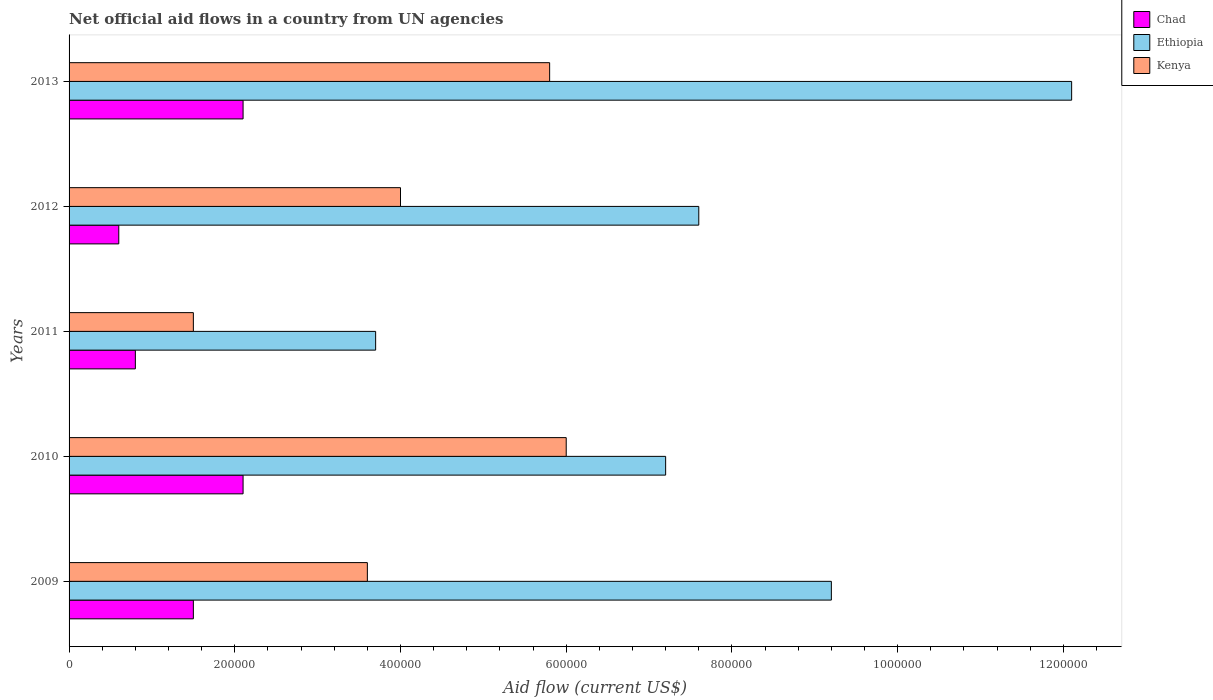What is the net official aid flow in Ethiopia in 2010?
Ensure brevity in your answer.  7.20e+05. Across all years, what is the maximum net official aid flow in Chad?
Your answer should be very brief. 2.10e+05. Across all years, what is the minimum net official aid flow in Chad?
Your response must be concise. 6.00e+04. In which year was the net official aid flow in Kenya maximum?
Your answer should be very brief. 2010. What is the total net official aid flow in Ethiopia in the graph?
Your answer should be compact. 3.98e+06. What is the difference between the net official aid flow in Kenya in 2009 and that in 2010?
Make the answer very short. -2.40e+05. What is the difference between the net official aid flow in Kenya in 2010 and the net official aid flow in Ethiopia in 2011?
Make the answer very short. 2.30e+05. What is the average net official aid flow in Chad per year?
Offer a very short reply. 1.42e+05. In the year 2011, what is the difference between the net official aid flow in Ethiopia and net official aid flow in Chad?
Your response must be concise. 2.90e+05. What is the ratio of the net official aid flow in Ethiopia in 2011 to that in 2013?
Keep it short and to the point. 0.31. Is the net official aid flow in Kenya in 2012 less than that in 2013?
Give a very brief answer. Yes. What is the difference between the highest and the lowest net official aid flow in Chad?
Your response must be concise. 1.50e+05. What does the 2nd bar from the top in 2013 represents?
Offer a very short reply. Ethiopia. What does the 1st bar from the bottom in 2012 represents?
Make the answer very short. Chad. Are all the bars in the graph horizontal?
Give a very brief answer. Yes. Are the values on the major ticks of X-axis written in scientific E-notation?
Your response must be concise. No. Where does the legend appear in the graph?
Your answer should be compact. Top right. How many legend labels are there?
Your response must be concise. 3. How are the legend labels stacked?
Provide a succinct answer. Vertical. What is the title of the graph?
Ensure brevity in your answer.  Net official aid flows in a country from UN agencies. What is the label or title of the Y-axis?
Provide a succinct answer. Years. What is the Aid flow (current US$) in Ethiopia in 2009?
Your answer should be compact. 9.20e+05. What is the Aid flow (current US$) in Kenya in 2009?
Offer a very short reply. 3.60e+05. What is the Aid flow (current US$) in Chad in 2010?
Your answer should be very brief. 2.10e+05. What is the Aid flow (current US$) of Ethiopia in 2010?
Provide a succinct answer. 7.20e+05. What is the Aid flow (current US$) of Kenya in 2010?
Give a very brief answer. 6.00e+05. What is the Aid flow (current US$) of Ethiopia in 2011?
Make the answer very short. 3.70e+05. What is the Aid flow (current US$) in Chad in 2012?
Make the answer very short. 6.00e+04. What is the Aid flow (current US$) of Ethiopia in 2012?
Make the answer very short. 7.60e+05. What is the Aid flow (current US$) of Ethiopia in 2013?
Offer a very short reply. 1.21e+06. What is the Aid flow (current US$) of Kenya in 2013?
Give a very brief answer. 5.80e+05. Across all years, what is the maximum Aid flow (current US$) of Ethiopia?
Your response must be concise. 1.21e+06. Across all years, what is the maximum Aid flow (current US$) in Kenya?
Give a very brief answer. 6.00e+05. Across all years, what is the minimum Aid flow (current US$) in Chad?
Ensure brevity in your answer.  6.00e+04. Across all years, what is the minimum Aid flow (current US$) in Kenya?
Make the answer very short. 1.50e+05. What is the total Aid flow (current US$) in Chad in the graph?
Provide a short and direct response. 7.10e+05. What is the total Aid flow (current US$) of Ethiopia in the graph?
Keep it short and to the point. 3.98e+06. What is the total Aid flow (current US$) in Kenya in the graph?
Make the answer very short. 2.09e+06. What is the difference between the Aid flow (current US$) in Chad in 2009 and that in 2010?
Provide a short and direct response. -6.00e+04. What is the difference between the Aid flow (current US$) of Kenya in 2009 and that in 2010?
Offer a very short reply. -2.40e+05. What is the difference between the Aid flow (current US$) of Ethiopia in 2009 and that in 2011?
Ensure brevity in your answer.  5.50e+05. What is the difference between the Aid flow (current US$) in Chad in 2009 and that in 2012?
Provide a short and direct response. 9.00e+04. What is the difference between the Aid flow (current US$) in Ethiopia in 2009 and that in 2012?
Provide a short and direct response. 1.60e+05. What is the difference between the Aid flow (current US$) in Kenya in 2009 and that in 2012?
Keep it short and to the point. -4.00e+04. What is the difference between the Aid flow (current US$) of Chad in 2009 and that in 2013?
Offer a very short reply. -6.00e+04. What is the difference between the Aid flow (current US$) in Chad in 2010 and that in 2011?
Ensure brevity in your answer.  1.30e+05. What is the difference between the Aid flow (current US$) of Ethiopia in 2010 and that in 2011?
Offer a very short reply. 3.50e+05. What is the difference between the Aid flow (current US$) in Kenya in 2010 and that in 2011?
Your response must be concise. 4.50e+05. What is the difference between the Aid flow (current US$) of Ethiopia in 2010 and that in 2012?
Make the answer very short. -4.00e+04. What is the difference between the Aid flow (current US$) of Chad in 2010 and that in 2013?
Provide a succinct answer. 0. What is the difference between the Aid flow (current US$) in Ethiopia in 2010 and that in 2013?
Ensure brevity in your answer.  -4.90e+05. What is the difference between the Aid flow (current US$) in Chad in 2011 and that in 2012?
Provide a succinct answer. 2.00e+04. What is the difference between the Aid flow (current US$) of Ethiopia in 2011 and that in 2012?
Ensure brevity in your answer.  -3.90e+05. What is the difference between the Aid flow (current US$) of Chad in 2011 and that in 2013?
Your response must be concise. -1.30e+05. What is the difference between the Aid flow (current US$) of Ethiopia in 2011 and that in 2013?
Make the answer very short. -8.40e+05. What is the difference between the Aid flow (current US$) of Kenya in 2011 and that in 2013?
Your response must be concise. -4.30e+05. What is the difference between the Aid flow (current US$) of Ethiopia in 2012 and that in 2013?
Provide a succinct answer. -4.50e+05. What is the difference between the Aid flow (current US$) in Chad in 2009 and the Aid flow (current US$) in Ethiopia in 2010?
Your answer should be very brief. -5.70e+05. What is the difference between the Aid flow (current US$) of Chad in 2009 and the Aid flow (current US$) of Kenya in 2010?
Your answer should be very brief. -4.50e+05. What is the difference between the Aid flow (current US$) of Chad in 2009 and the Aid flow (current US$) of Kenya in 2011?
Keep it short and to the point. 0. What is the difference between the Aid flow (current US$) of Ethiopia in 2009 and the Aid flow (current US$) of Kenya in 2011?
Your answer should be compact. 7.70e+05. What is the difference between the Aid flow (current US$) in Chad in 2009 and the Aid flow (current US$) in Ethiopia in 2012?
Provide a succinct answer. -6.10e+05. What is the difference between the Aid flow (current US$) of Chad in 2009 and the Aid flow (current US$) of Kenya in 2012?
Your answer should be compact. -2.50e+05. What is the difference between the Aid flow (current US$) of Ethiopia in 2009 and the Aid flow (current US$) of Kenya in 2012?
Provide a short and direct response. 5.20e+05. What is the difference between the Aid flow (current US$) of Chad in 2009 and the Aid flow (current US$) of Ethiopia in 2013?
Keep it short and to the point. -1.06e+06. What is the difference between the Aid flow (current US$) in Chad in 2009 and the Aid flow (current US$) in Kenya in 2013?
Provide a short and direct response. -4.30e+05. What is the difference between the Aid flow (current US$) of Ethiopia in 2009 and the Aid flow (current US$) of Kenya in 2013?
Ensure brevity in your answer.  3.40e+05. What is the difference between the Aid flow (current US$) in Chad in 2010 and the Aid flow (current US$) in Ethiopia in 2011?
Your answer should be very brief. -1.60e+05. What is the difference between the Aid flow (current US$) of Chad in 2010 and the Aid flow (current US$) of Kenya in 2011?
Your answer should be very brief. 6.00e+04. What is the difference between the Aid flow (current US$) of Ethiopia in 2010 and the Aid flow (current US$) of Kenya in 2011?
Provide a short and direct response. 5.70e+05. What is the difference between the Aid flow (current US$) of Chad in 2010 and the Aid flow (current US$) of Ethiopia in 2012?
Ensure brevity in your answer.  -5.50e+05. What is the difference between the Aid flow (current US$) in Chad in 2010 and the Aid flow (current US$) in Ethiopia in 2013?
Ensure brevity in your answer.  -1.00e+06. What is the difference between the Aid flow (current US$) in Chad in 2010 and the Aid flow (current US$) in Kenya in 2013?
Your response must be concise. -3.70e+05. What is the difference between the Aid flow (current US$) in Ethiopia in 2010 and the Aid flow (current US$) in Kenya in 2013?
Provide a short and direct response. 1.40e+05. What is the difference between the Aid flow (current US$) of Chad in 2011 and the Aid flow (current US$) of Ethiopia in 2012?
Make the answer very short. -6.80e+05. What is the difference between the Aid flow (current US$) in Chad in 2011 and the Aid flow (current US$) in Kenya in 2012?
Provide a short and direct response. -3.20e+05. What is the difference between the Aid flow (current US$) in Chad in 2011 and the Aid flow (current US$) in Ethiopia in 2013?
Your answer should be very brief. -1.13e+06. What is the difference between the Aid flow (current US$) in Chad in 2011 and the Aid flow (current US$) in Kenya in 2013?
Offer a very short reply. -5.00e+05. What is the difference between the Aid flow (current US$) in Ethiopia in 2011 and the Aid flow (current US$) in Kenya in 2013?
Make the answer very short. -2.10e+05. What is the difference between the Aid flow (current US$) in Chad in 2012 and the Aid flow (current US$) in Ethiopia in 2013?
Ensure brevity in your answer.  -1.15e+06. What is the difference between the Aid flow (current US$) of Chad in 2012 and the Aid flow (current US$) of Kenya in 2013?
Make the answer very short. -5.20e+05. What is the difference between the Aid flow (current US$) in Ethiopia in 2012 and the Aid flow (current US$) in Kenya in 2013?
Provide a short and direct response. 1.80e+05. What is the average Aid flow (current US$) of Chad per year?
Keep it short and to the point. 1.42e+05. What is the average Aid flow (current US$) in Ethiopia per year?
Make the answer very short. 7.96e+05. What is the average Aid flow (current US$) of Kenya per year?
Provide a short and direct response. 4.18e+05. In the year 2009, what is the difference between the Aid flow (current US$) in Chad and Aid flow (current US$) in Ethiopia?
Keep it short and to the point. -7.70e+05. In the year 2009, what is the difference between the Aid flow (current US$) in Ethiopia and Aid flow (current US$) in Kenya?
Provide a succinct answer. 5.60e+05. In the year 2010, what is the difference between the Aid flow (current US$) of Chad and Aid flow (current US$) of Ethiopia?
Offer a very short reply. -5.10e+05. In the year 2010, what is the difference between the Aid flow (current US$) of Chad and Aid flow (current US$) of Kenya?
Ensure brevity in your answer.  -3.90e+05. In the year 2011, what is the difference between the Aid flow (current US$) in Chad and Aid flow (current US$) in Ethiopia?
Your answer should be very brief. -2.90e+05. In the year 2012, what is the difference between the Aid flow (current US$) of Chad and Aid flow (current US$) of Ethiopia?
Your answer should be compact. -7.00e+05. In the year 2012, what is the difference between the Aid flow (current US$) in Chad and Aid flow (current US$) in Kenya?
Offer a very short reply. -3.40e+05. In the year 2012, what is the difference between the Aid flow (current US$) in Ethiopia and Aid flow (current US$) in Kenya?
Give a very brief answer. 3.60e+05. In the year 2013, what is the difference between the Aid flow (current US$) of Chad and Aid flow (current US$) of Kenya?
Your answer should be very brief. -3.70e+05. In the year 2013, what is the difference between the Aid flow (current US$) of Ethiopia and Aid flow (current US$) of Kenya?
Give a very brief answer. 6.30e+05. What is the ratio of the Aid flow (current US$) in Ethiopia in 2009 to that in 2010?
Provide a succinct answer. 1.28. What is the ratio of the Aid flow (current US$) in Chad in 2009 to that in 2011?
Provide a short and direct response. 1.88. What is the ratio of the Aid flow (current US$) of Ethiopia in 2009 to that in 2011?
Ensure brevity in your answer.  2.49. What is the ratio of the Aid flow (current US$) of Kenya in 2009 to that in 2011?
Your answer should be very brief. 2.4. What is the ratio of the Aid flow (current US$) of Chad in 2009 to that in 2012?
Your answer should be compact. 2.5. What is the ratio of the Aid flow (current US$) of Ethiopia in 2009 to that in 2012?
Offer a terse response. 1.21. What is the ratio of the Aid flow (current US$) in Kenya in 2009 to that in 2012?
Your response must be concise. 0.9. What is the ratio of the Aid flow (current US$) in Chad in 2009 to that in 2013?
Ensure brevity in your answer.  0.71. What is the ratio of the Aid flow (current US$) of Ethiopia in 2009 to that in 2013?
Give a very brief answer. 0.76. What is the ratio of the Aid flow (current US$) in Kenya in 2009 to that in 2013?
Offer a very short reply. 0.62. What is the ratio of the Aid flow (current US$) in Chad in 2010 to that in 2011?
Your response must be concise. 2.62. What is the ratio of the Aid flow (current US$) in Ethiopia in 2010 to that in 2011?
Offer a terse response. 1.95. What is the ratio of the Aid flow (current US$) of Chad in 2010 to that in 2012?
Give a very brief answer. 3.5. What is the ratio of the Aid flow (current US$) of Ethiopia in 2010 to that in 2012?
Offer a terse response. 0.95. What is the ratio of the Aid flow (current US$) in Kenya in 2010 to that in 2012?
Provide a short and direct response. 1.5. What is the ratio of the Aid flow (current US$) of Ethiopia in 2010 to that in 2013?
Provide a short and direct response. 0.59. What is the ratio of the Aid flow (current US$) in Kenya in 2010 to that in 2013?
Your response must be concise. 1.03. What is the ratio of the Aid flow (current US$) in Ethiopia in 2011 to that in 2012?
Provide a succinct answer. 0.49. What is the ratio of the Aid flow (current US$) of Kenya in 2011 to that in 2012?
Your response must be concise. 0.38. What is the ratio of the Aid flow (current US$) of Chad in 2011 to that in 2013?
Ensure brevity in your answer.  0.38. What is the ratio of the Aid flow (current US$) in Ethiopia in 2011 to that in 2013?
Make the answer very short. 0.31. What is the ratio of the Aid flow (current US$) of Kenya in 2011 to that in 2013?
Provide a short and direct response. 0.26. What is the ratio of the Aid flow (current US$) of Chad in 2012 to that in 2013?
Make the answer very short. 0.29. What is the ratio of the Aid flow (current US$) of Ethiopia in 2012 to that in 2013?
Give a very brief answer. 0.63. What is the ratio of the Aid flow (current US$) of Kenya in 2012 to that in 2013?
Keep it short and to the point. 0.69. What is the difference between the highest and the second highest Aid flow (current US$) in Chad?
Give a very brief answer. 0. What is the difference between the highest and the second highest Aid flow (current US$) in Ethiopia?
Offer a very short reply. 2.90e+05. What is the difference between the highest and the second highest Aid flow (current US$) of Kenya?
Your answer should be compact. 2.00e+04. What is the difference between the highest and the lowest Aid flow (current US$) in Chad?
Your answer should be very brief. 1.50e+05. What is the difference between the highest and the lowest Aid flow (current US$) of Ethiopia?
Keep it short and to the point. 8.40e+05. 